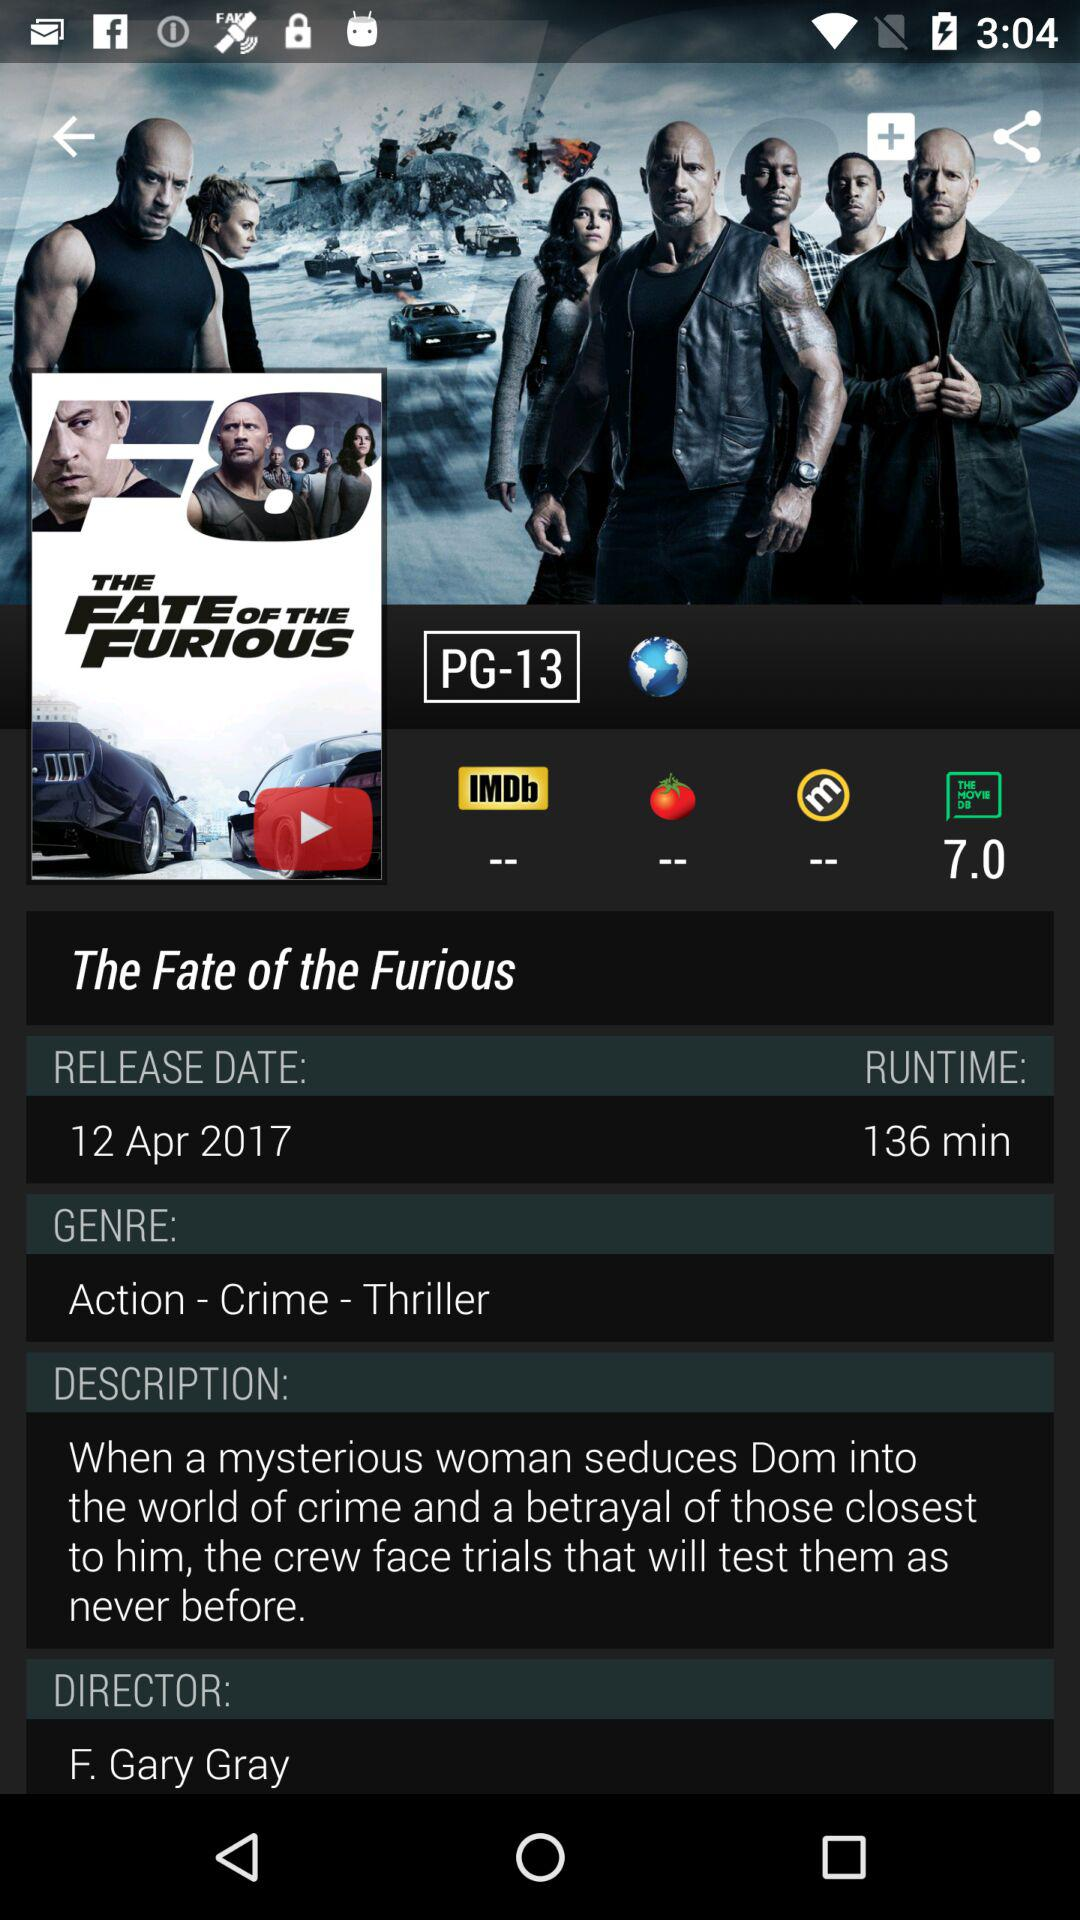What's the duration of the movie? The duration of the movie is 136 minutes. 